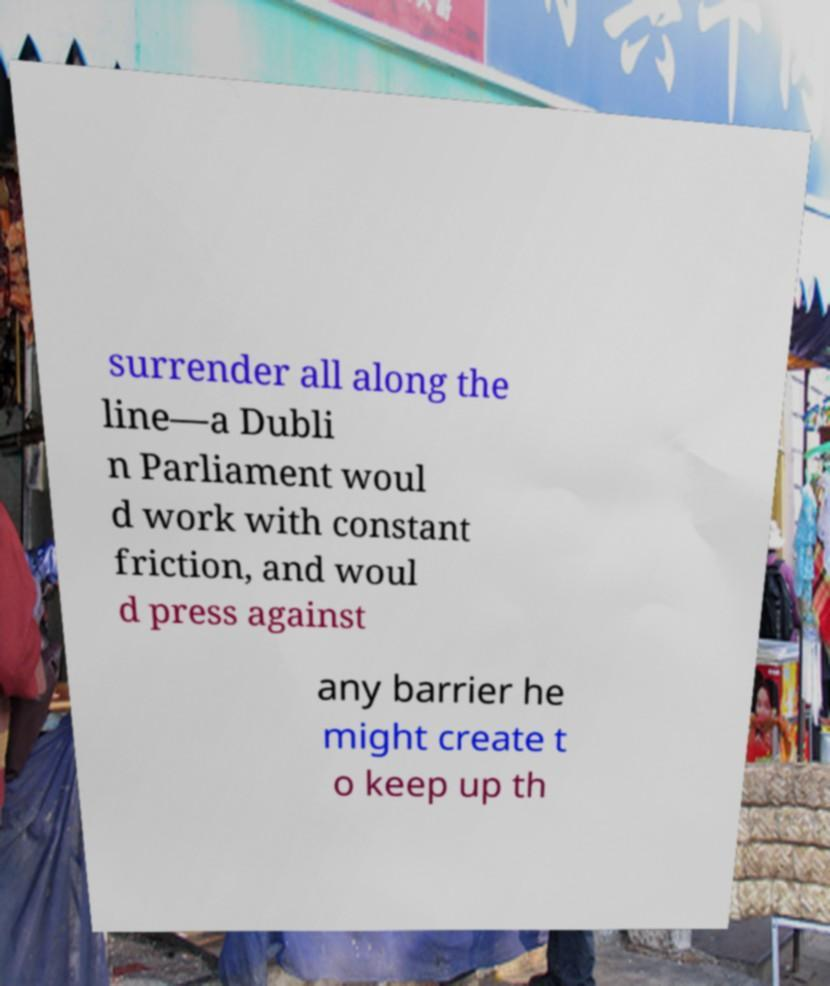I need the written content from this picture converted into text. Can you do that? surrender all along the line—a Dubli n Parliament woul d work with constant friction, and woul d press against any barrier he might create t o keep up th 